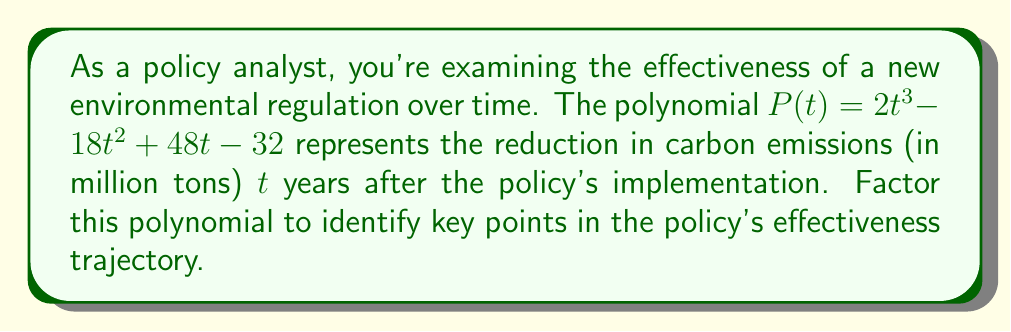Provide a solution to this math problem. To factor this polynomial, we'll follow these steps:

1) First, let's check if there's a common factor:
   $P(t) = 2t^3 - 18t^2 + 48t - 32$
   There's no common factor for all terms.

2) This is a cubic polynomial. Let's try to find a factor by guessing roots. The possible rational roots are factors of the constant term: ±1, ±2, ±4, ±8, ±16, ±32.

3) Testing these values, we find that $P(2) = 0$. So $(t-2)$ is a factor.

4) Divide $P(t)$ by $(t-2)$ using polynomial long division:

   $$
   \begin{array}{r}
   2t^2 - 14t + 20 \\
   t - 2 \enclose{longdiv}{2t^3 - 18t^2 + 48t - 32} \\
   \underline{2t^3 - 4t^2} \\
   -14t^2 + 48t \\
   \underline{-14t^2 + 28t} \\
   20t - 32 \\
   \underline{20t - 40} \\
   8
   \end{array}
   $$

5) So, $P(t) = (t-2)(2t^2 - 14t + 20)$

6) Now, let's factor the quadratic term $2t^2 - 14t + 20$:
   
   The discriminant $b^2 - 4ac = (-14)^2 - 4(2)(20) = 196 - 160 = 36 = 6^2$
   
   So the roots are $\frac{14 \pm 6}{2(2)} = \frac{14 \pm 6}{4}$

   The roots are 5 and 2.

7) Therefore, the fully factored polynomial is:

   $P(t) = 2(t-2)(t-5)(t-2)$

This factorization reveals that the policy's effectiveness has critical points at $t = 2$ and $t = 5$ years after implementation. The repeated root at $t = 2$ suggests a possible inflection point in the policy's effectiveness at this time.
Answer: $P(t) = 2(t-2)^2(t-5)$ 